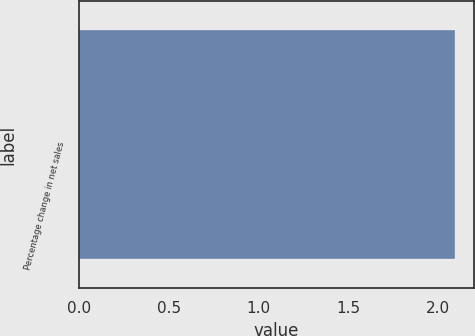<chart> <loc_0><loc_0><loc_500><loc_500><bar_chart><fcel>Percentage change in net sales<nl><fcel>2.1<nl></chart> 